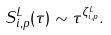Convert formula to latex. <formula><loc_0><loc_0><loc_500><loc_500>S ^ { L } _ { i , p } ( \tau ) \sim \tau ^ { \zeta ^ { L } _ { i , p } } .</formula> 